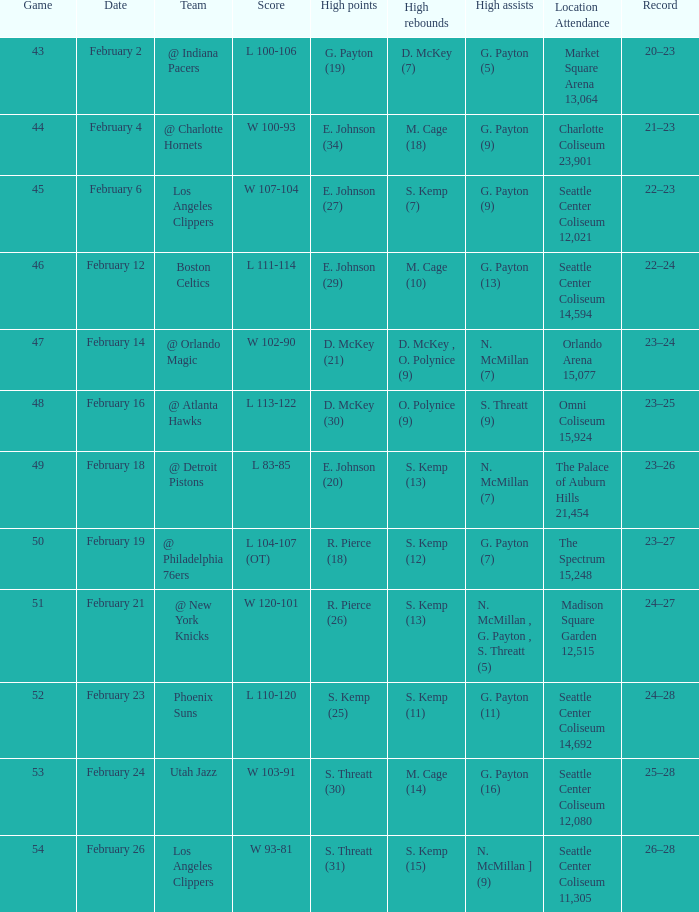What is the utah jazz's performance history? 25–28. 